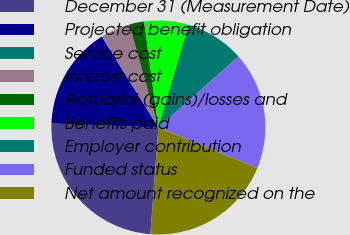<chart> <loc_0><loc_0><loc_500><loc_500><pie_chart><fcel>December 31 (Measurement Date)<fcel>Projected benefit obligation<fcel>Service cost<fcel>Interest cost<fcel>Actuarial (gains)/losses and<fcel>Benefits paid<fcel>Employer contribution<fcel>Funded status<fcel>Net amount recognized on the<nl><fcel>24.4%<fcel>15.54%<fcel>0.03%<fcel>4.46%<fcel>2.25%<fcel>6.68%<fcel>8.9%<fcel>17.76%<fcel>19.97%<nl></chart> 